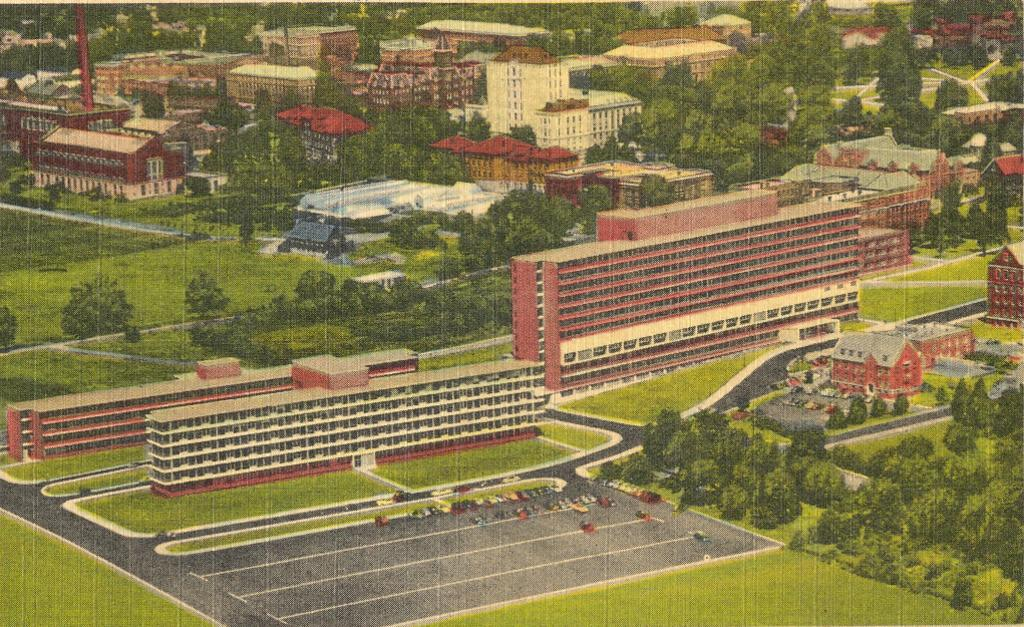What type of structures can be seen in the image? There are buildings in the image. What natural elements are present in the image? There are trees and grass in the image. What man-made elements are present in the image? There are roads in the image. Can you describe the unspecified objects in the image? Unfortunately, the provided facts do not specify the nature of these objects. Where is the drawer located in the image? There is no drawer present in the image. What type of glass can be seen in the image? There is no glass present in the image. 